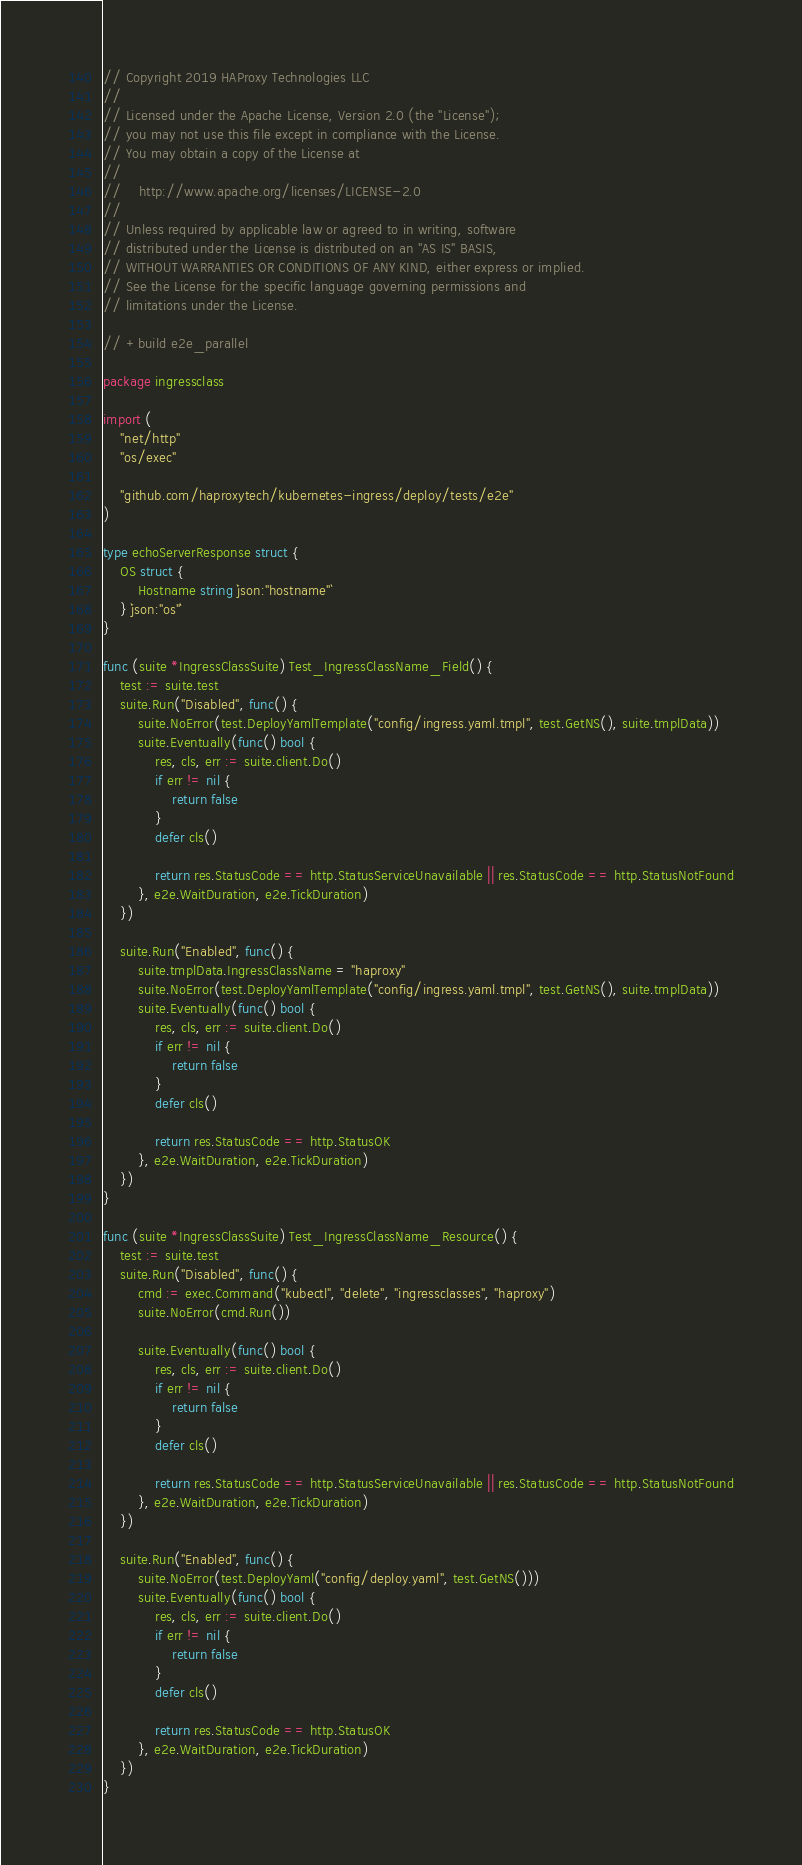<code> <loc_0><loc_0><loc_500><loc_500><_Go_>// Copyright 2019 HAProxy Technologies LLC
//
// Licensed under the Apache License, Version 2.0 (the "License");
// you may not use this file except in compliance with the License.
// You may obtain a copy of the License at
//
//    http://www.apache.org/licenses/LICENSE-2.0
//
// Unless required by applicable law or agreed to in writing, software
// distributed under the License is distributed on an "AS IS" BASIS,
// WITHOUT WARRANTIES OR CONDITIONS OF ANY KIND, either express or implied.
// See the License for the specific language governing permissions and
// limitations under the License.

// +build e2e_parallel

package ingressclass

import (
	"net/http"
	"os/exec"

	"github.com/haproxytech/kubernetes-ingress/deploy/tests/e2e"
)

type echoServerResponse struct {
	OS struct {
		Hostname string `json:"hostname"`
	} `json:"os"`
}

func (suite *IngressClassSuite) Test_IngressClassName_Field() {
	test := suite.test
	suite.Run("Disabled", func() {
		suite.NoError(test.DeployYamlTemplate("config/ingress.yaml.tmpl", test.GetNS(), suite.tmplData))
		suite.Eventually(func() bool {
			res, cls, err := suite.client.Do()
			if err != nil {
				return false
			}
			defer cls()

			return res.StatusCode == http.StatusServiceUnavailable || res.StatusCode == http.StatusNotFound
		}, e2e.WaitDuration, e2e.TickDuration)
	})

	suite.Run("Enabled", func() {
		suite.tmplData.IngressClassName = "haproxy"
		suite.NoError(test.DeployYamlTemplate("config/ingress.yaml.tmpl", test.GetNS(), suite.tmplData))
		suite.Eventually(func() bool {
			res, cls, err := suite.client.Do()
			if err != nil {
				return false
			}
			defer cls()

			return res.StatusCode == http.StatusOK
		}, e2e.WaitDuration, e2e.TickDuration)
	})
}

func (suite *IngressClassSuite) Test_IngressClassName_Resource() {
	test := suite.test
	suite.Run("Disabled", func() {
		cmd := exec.Command("kubectl", "delete", "ingressclasses", "haproxy")
		suite.NoError(cmd.Run())

		suite.Eventually(func() bool {
			res, cls, err := suite.client.Do()
			if err != nil {
				return false
			}
			defer cls()

			return res.StatusCode == http.StatusServiceUnavailable || res.StatusCode == http.StatusNotFound
		}, e2e.WaitDuration, e2e.TickDuration)
	})

	suite.Run("Enabled", func() {
		suite.NoError(test.DeployYaml("config/deploy.yaml", test.GetNS()))
		suite.Eventually(func() bool {
			res, cls, err := suite.client.Do()
			if err != nil {
				return false
			}
			defer cls()

			return res.StatusCode == http.StatusOK
		}, e2e.WaitDuration, e2e.TickDuration)
	})
}
</code> 